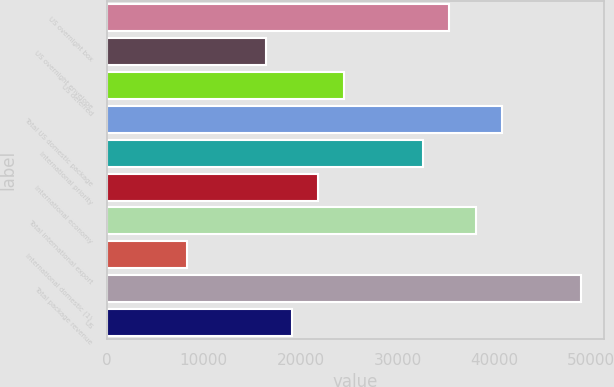Convert chart. <chart><loc_0><loc_0><loc_500><loc_500><bar_chart><fcel>US overnight box<fcel>US overnight envelope<fcel>US deferred<fcel>Total US domestic package<fcel>International priority<fcel>International economy<fcel>Total international export<fcel>International domestic (1)<fcel>Total package revenue<fcel>US<nl><fcel>35356.7<fcel>16415.4<fcel>24533.1<fcel>40768.5<fcel>32650.8<fcel>21827.2<fcel>38062.6<fcel>8297.7<fcel>48886.2<fcel>19121.3<nl></chart> 